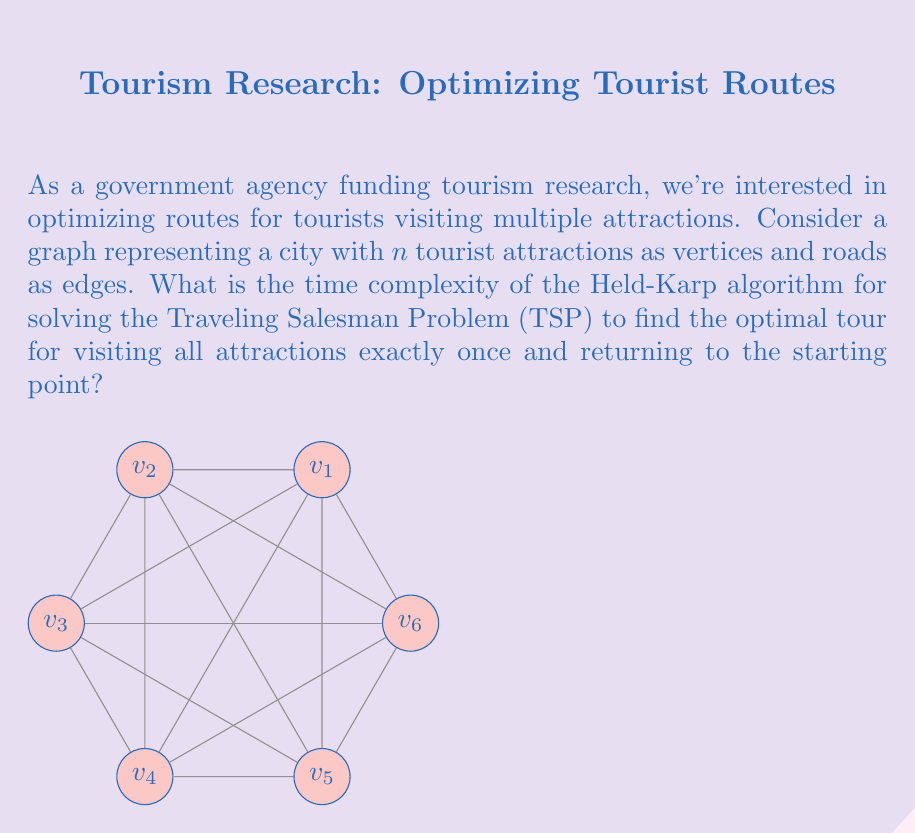Teach me how to tackle this problem. To analyze the time complexity of the Held-Karp algorithm for the TSP:

1) The Held-Karp algorithm uses dynamic programming to solve the TSP.

2) It considers all possible subsets of vertices and all possible last vertices for each subset.

3) For each subset $S$ of size $k$ (where $2 \leq k \leq n$) and each vertex $v \in S$, it computes the cost of the optimal path visiting all vertices in $S$ exactly once, ending at $v$.

4) The number of subsets of size $k$ is $\binom{n}{k}$.

5) For each subset, we consider $k$ possible end vertices.

6) For each end vertex, we consider $k-1$ possible previous vertices.

7) The recurrence relation used is:
   $$C(S,v) = \min_{u \in S, u \neq v} \{C(S-\{v\}, u) + d(u,v)\}$$
   where $C(S,v)$ is the cost of the optimal path ending at $v$ visiting all vertices in $S$, and $d(u,v)$ is the distance between $u$ and $v$.

8) The total number of subproblems solved is:
   $$\sum_{k=2}^n \binom{n}{k} \cdot k = \sum_{k=2}^n \binom{n}{k} \cdot k = O(n^2 \cdot 2^n)$$

9) Each subproblem takes $O(n)$ time to solve.

Therefore, the overall time complexity of the Held-Karp algorithm is $O(n^2 \cdot 2^n \cdot n) = O(n^3 \cdot 2^n)$.
Answer: $O(n^3 \cdot 2^n)$ 